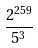<formula> <loc_0><loc_0><loc_500><loc_500>\frac { 2 ^ { 2 5 9 } } { 5 ^ { 3 } }</formula> 